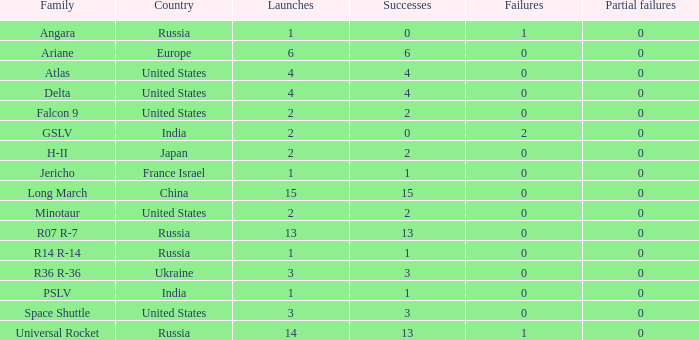What is the count of failure for the state of russia, and a family of r14 r-14, and a partial failures below 0? 0.0. 